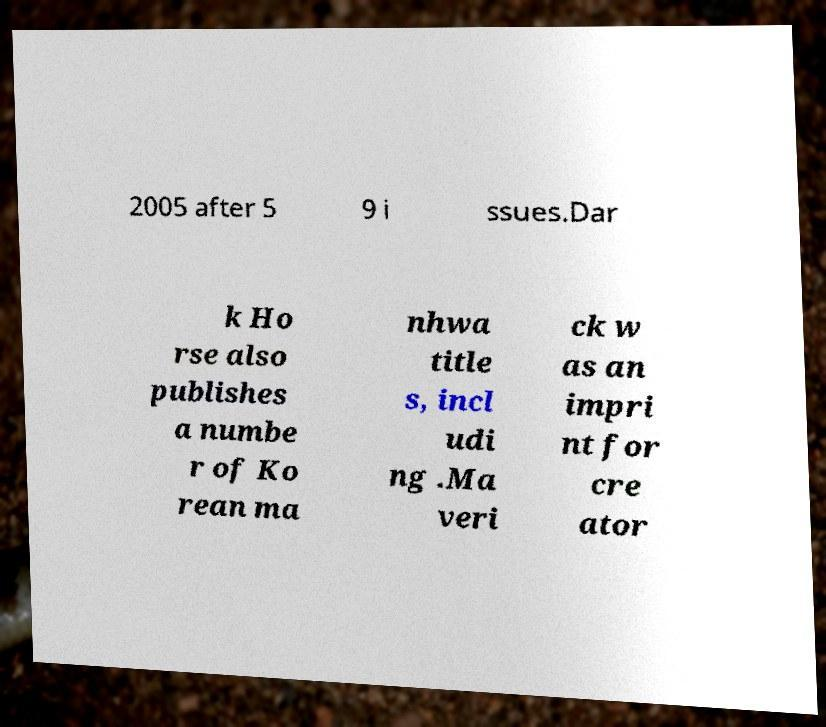Can you accurately transcribe the text from the provided image for me? 2005 after 5 9 i ssues.Dar k Ho rse also publishes a numbe r of Ko rean ma nhwa title s, incl udi ng .Ma veri ck w as an impri nt for cre ator 